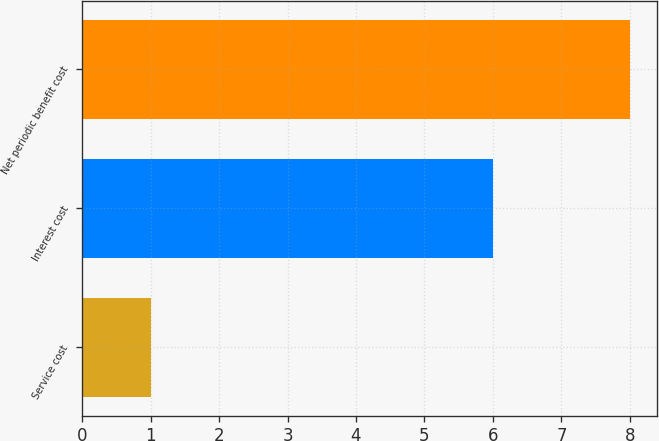Convert chart. <chart><loc_0><loc_0><loc_500><loc_500><bar_chart><fcel>Service cost<fcel>Interest cost<fcel>Net periodic benefit cost<nl><fcel>1<fcel>6<fcel>8<nl></chart> 